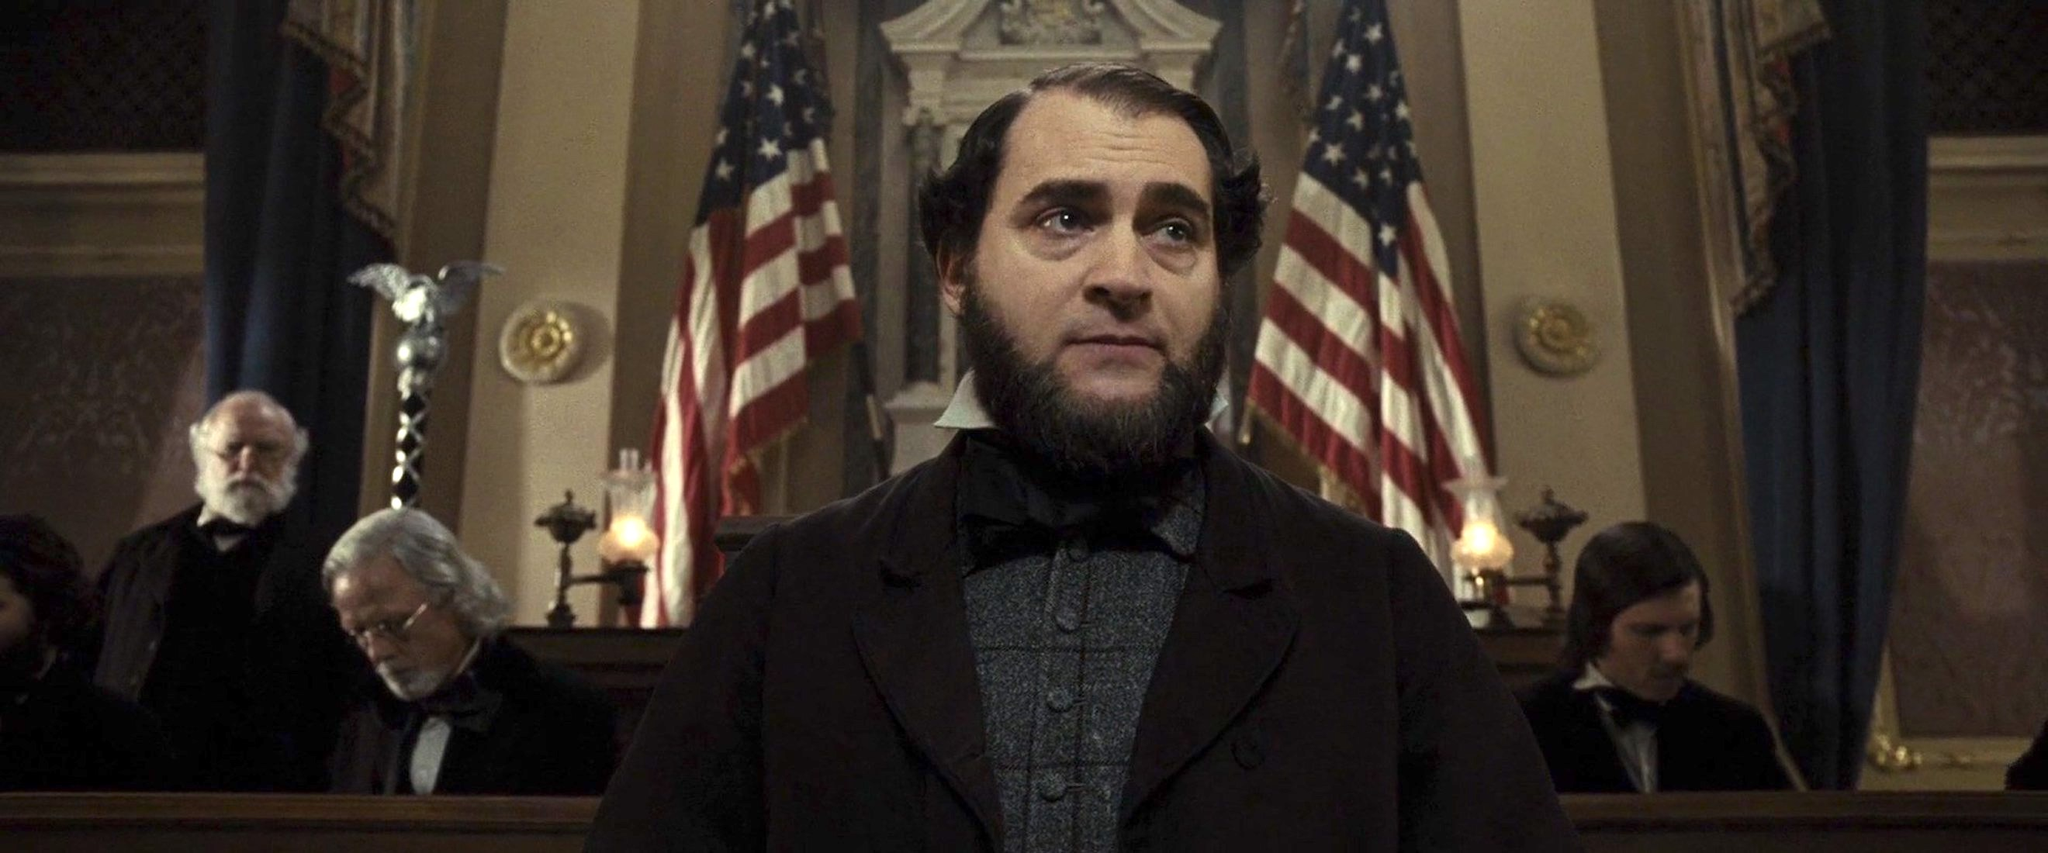Describe what you see in the historical context of this setting. In this historical setting, we see a solemn courtroom scene that evokes the 19th century. The central figure, likely a lawyer or a notable public figure, stands at a podium with American flags behind him, indicating this is a significant public or governmental proceeding. The decor and attire suggest a period of legal or political deliberation. The flags and the thoughtful expressions of the individuals in the background underscore the gravity of the situation, perhaps related to a critical historical event or decision. Can you elaborate on what this important decision might be? Given the historical ambiance and formal courtroom setting, it's plausible that the scene is depicting a momentous decision during a period of intense political or legal discourse, possibly during the Civil War or Reconstruction era in the United States. The presence of prominent flags and the serious demeanor of the figure suggest an important speech or ruling that could shape the nation's future, perhaps addressing issues of governance, civil rights, or statehood. Imagine if this courtroom could witness a historical debate between founding fathers. How would that look? If this courtroom could witness a historical debate between the founding fathers, it would be a scene filled with impassioned arguments and profound rhetoric. Figures like Thomas Jefferson, John Adams, and Alexander Hamilton would stand at the podium, framed by the sharegpt4v/same American flags symbolizing their unyielding commitment to the nation. The courtroom would be abuzz with tension, as these towering figures engage in spirited discussions about the Constitution, states' rights, and the future of the newly formed republic. The atmosphere would be electrifying, filled with the ideals and convictions that shaped the United States' foundational principles. 